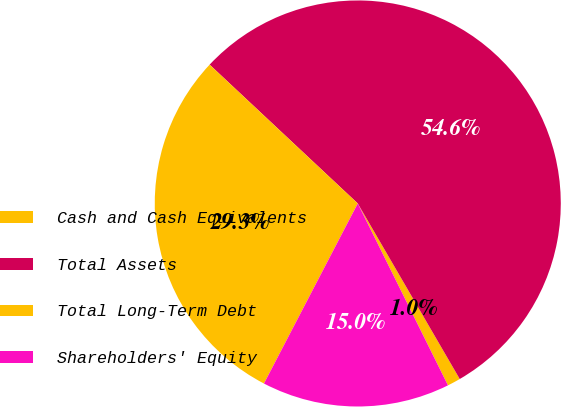Convert chart to OTSL. <chart><loc_0><loc_0><loc_500><loc_500><pie_chart><fcel>Cash and Cash Equivalents<fcel>Total Assets<fcel>Total Long-Term Debt<fcel>Shareholders' Equity<nl><fcel>1.05%<fcel>54.64%<fcel>29.34%<fcel>14.97%<nl></chart> 